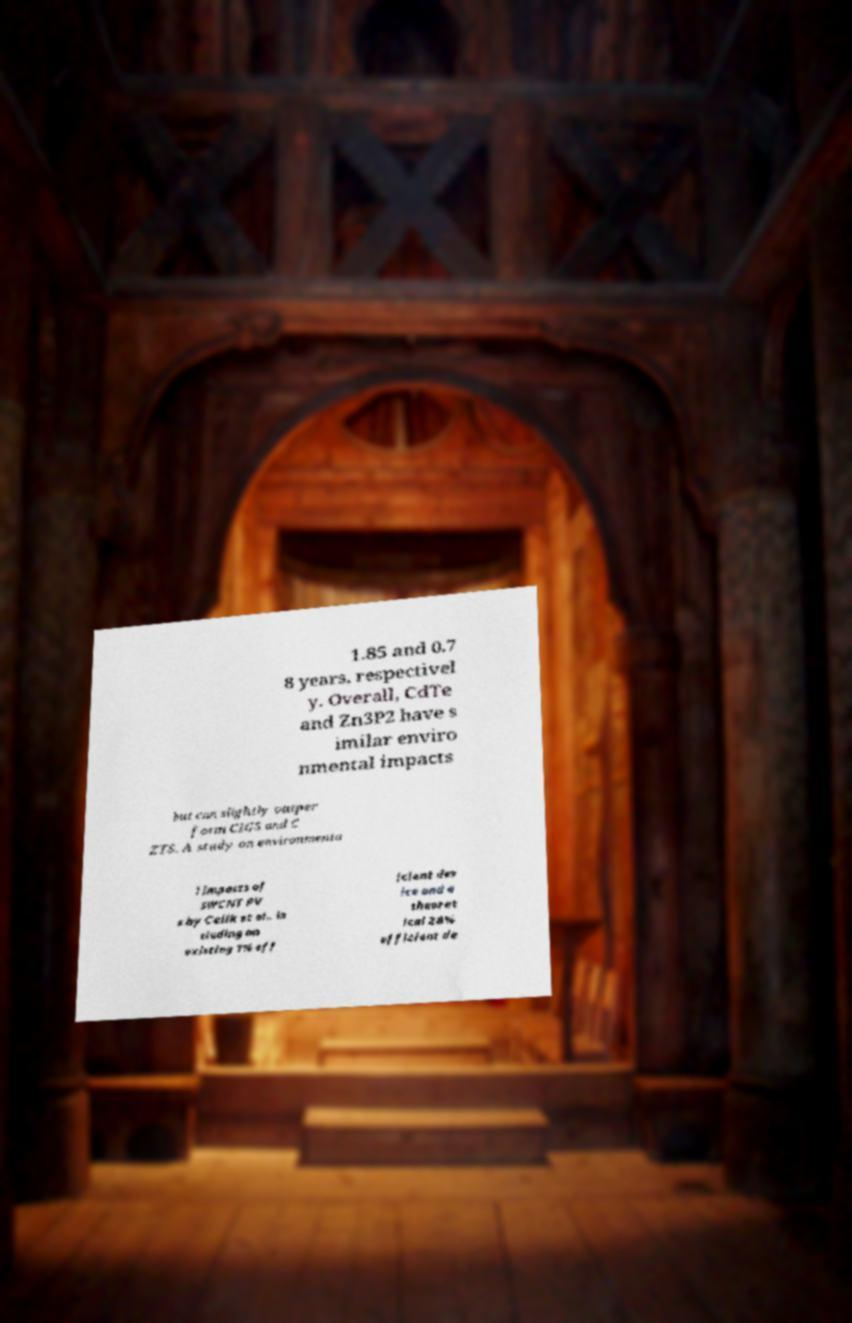Can you read and provide the text displayed in the image?This photo seems to have some interesting text. Can you extract and type it out for me? 1.85 and 0.7 8 years, respectivel y. Overall, CdTe and Zn3P2 have s imilar enviro nmental impacts but can slightly outper form CIGS and C ZTS. A study on environmenta l impacts of SWCNT PV s by Celik et al., in cluding an existing 1% eff icient dev ice and a theoret ical 28% efficient de 